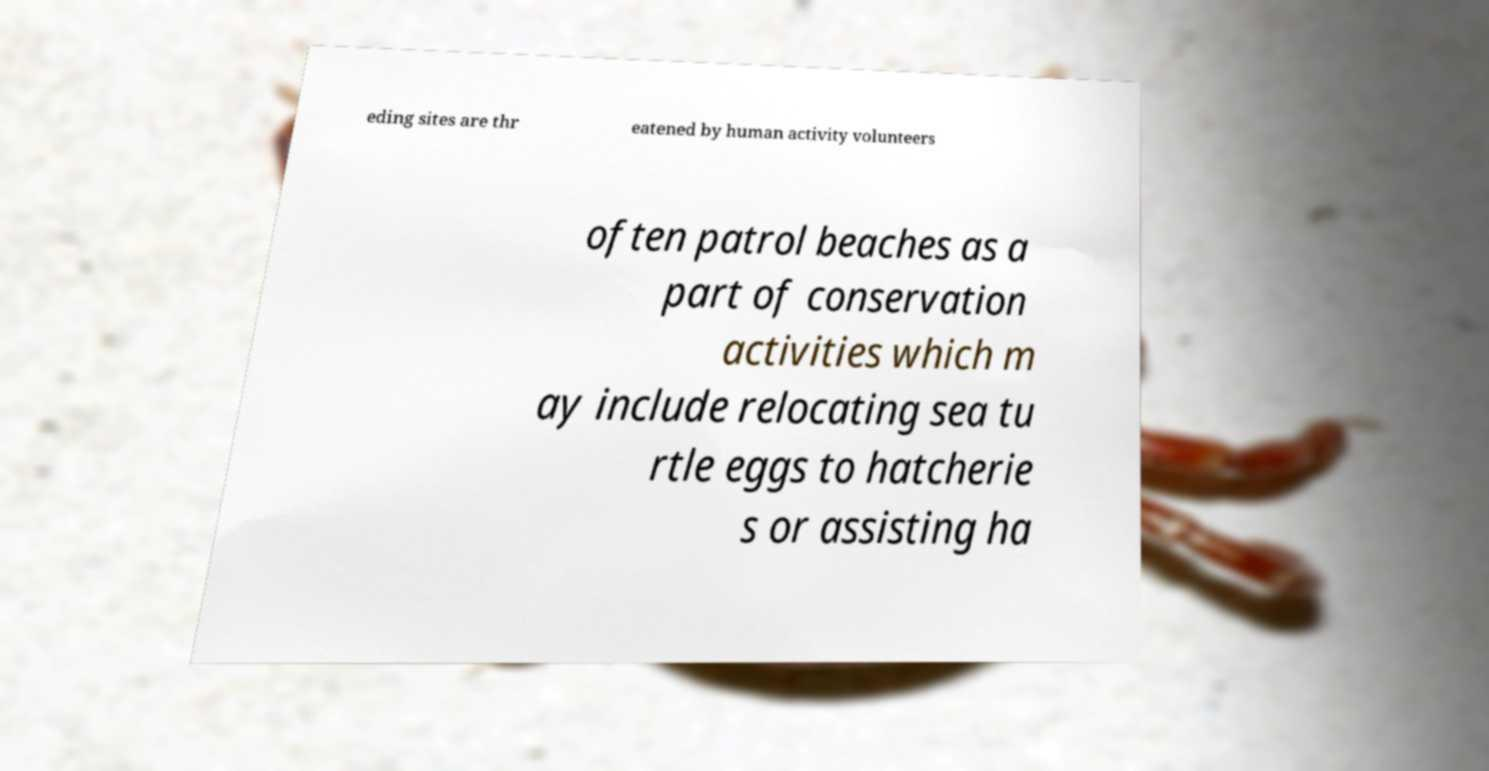Can you accurately transcribe the text from the provided image for me? eding sites are thr eatened by human activity volunteers often patrol beaches as a part of conservation activities which m ay include relocating sea tu rtle eggs to hatcherie s or assisting ha 